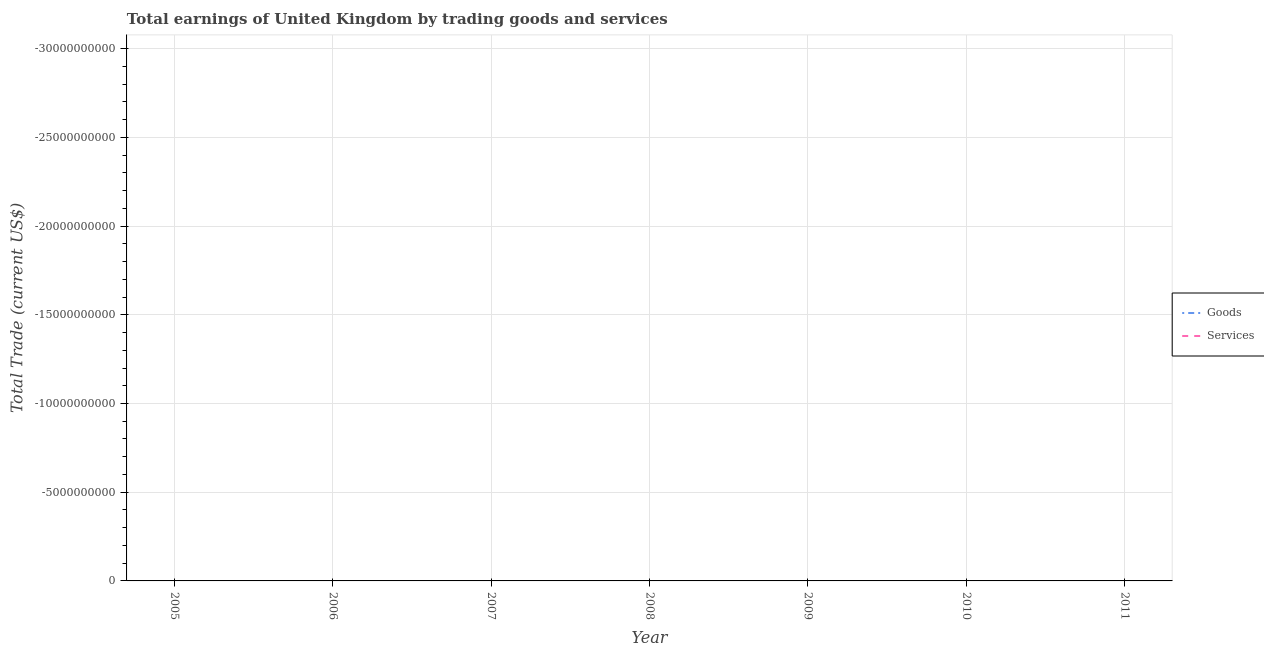What is the amount earned by trading goods in 2008?
Provide a succinct answer. 0. Across all years, what is the minimum amount earned by trading services?
Provide a short and direct response. 0. What is the average amount earned by trading services per year?
Provide a succinct answer. 0. Is the amount earned by trading goods strictly greater than the amount earned by trading services over the years?
Provide a short and direct response. No. Is the amount earned by trading services strictly less than the amount earned by trading goods over the years?
Provide a short and direct response. No. How many years are there in the graph?
Give a very brief answer. 7. What is the difference between two consecutive major ticks on the Y-axis?
Give a very brief answer. 5.00e+09. Are the values on the major ticks of Y-axis written in scientific E-notation?
Offer a very short reply. No. Does the graph contain any zero values?
Make the answer very short. Yes. Does the graph contain grids?
Ensure brevity in your answer.  Yes. How many legend labels are there?
Provide a short and direct response. 2. What is the title of the graph?
Provide a short and direct response. Total earnings of United Kingdom by trading goods and services. Does "Mobile cellular" appear as one of the legend labels in the graph?
Make the answer very short. No. What is the label or title of the Y-axis?
Keep it short and to the point. Total Trade (current US$). What is the Total Trade (current US$) in Services in 2006?
Your answer should be compact. 0. What is the Total Trade (current US$) in Goods in 2008?
Offer a terse response. 0. What is the Total Trade (current US$) in Services in 2008?
Provide a short and direct response. 0. What is the Total Trade (current US$) in Goods in 2009?
Your answer should be very brief. 0. What is the Total Trade (current US$) in Services in 2010?
Your answer should be very brief. 0. What is the Total Trade (current US$) of Goods in 2011?
Keep it short and to the point. 0. What is the total Total Trade (current US$) of Services in the graph?
Make the answer very short. 0. 